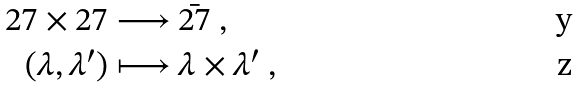<formula> <loc_0><loc_0><loc_500><loc_500>{ 2 7 } \times { 2 7 } \longrightarrow \ & { \bar { 2 7 } } \ , \\ ( \lambda , \lambda ^ { \prime } ) \longmapsto \ & \lambda \times \lambda ^ { \prime } \ ,</formula> 